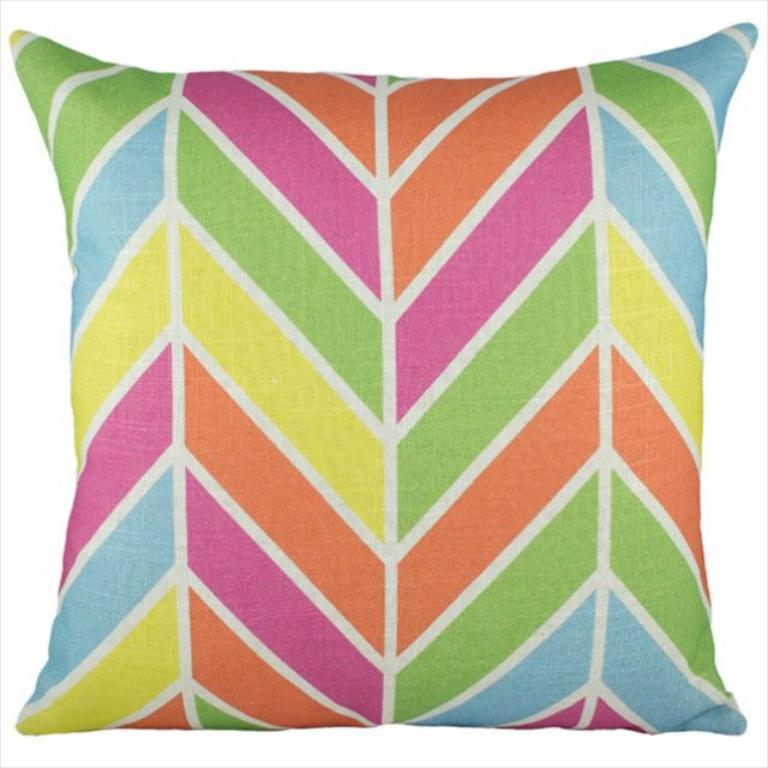In one or two sentences, can you explain what this image depicts? In this picture we can see a pillow. 